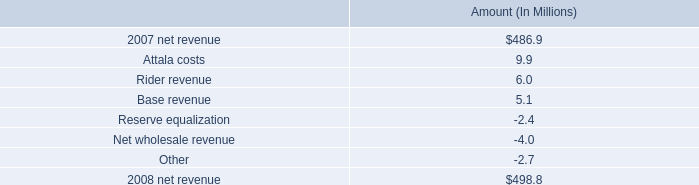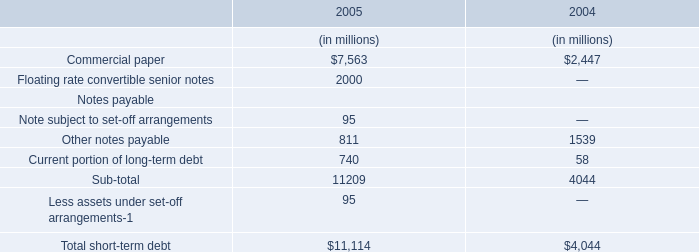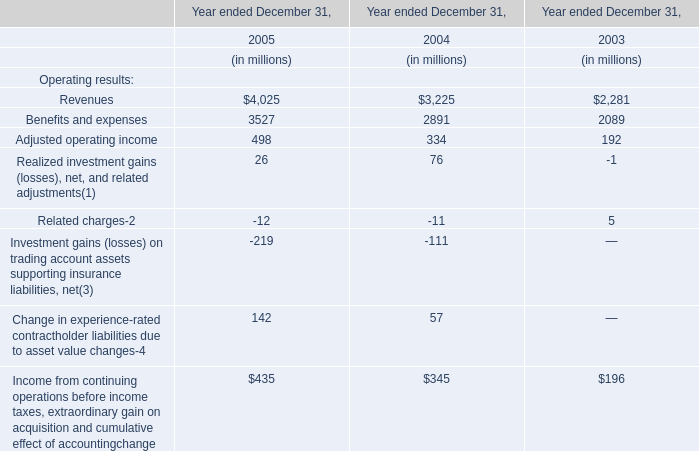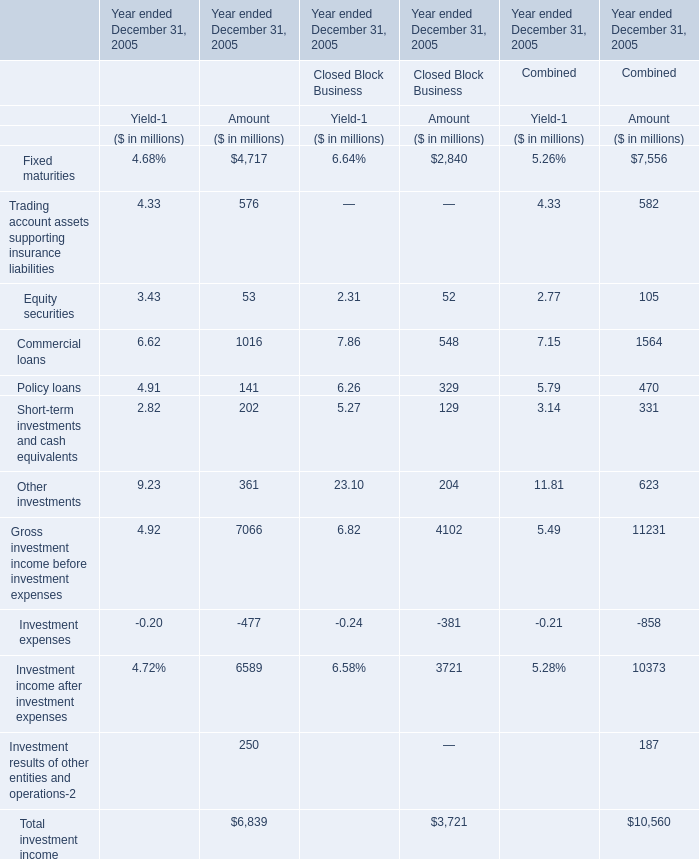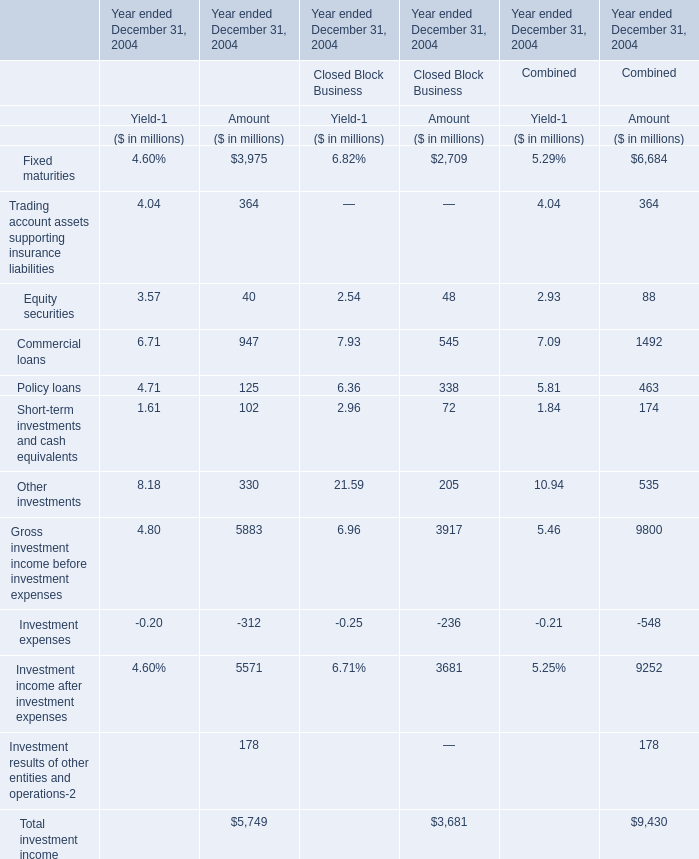Does the average value of Fixed maturities inFinancial Services Businesses greater than that in Closed Block Business for amount? 
Answer: yes. 